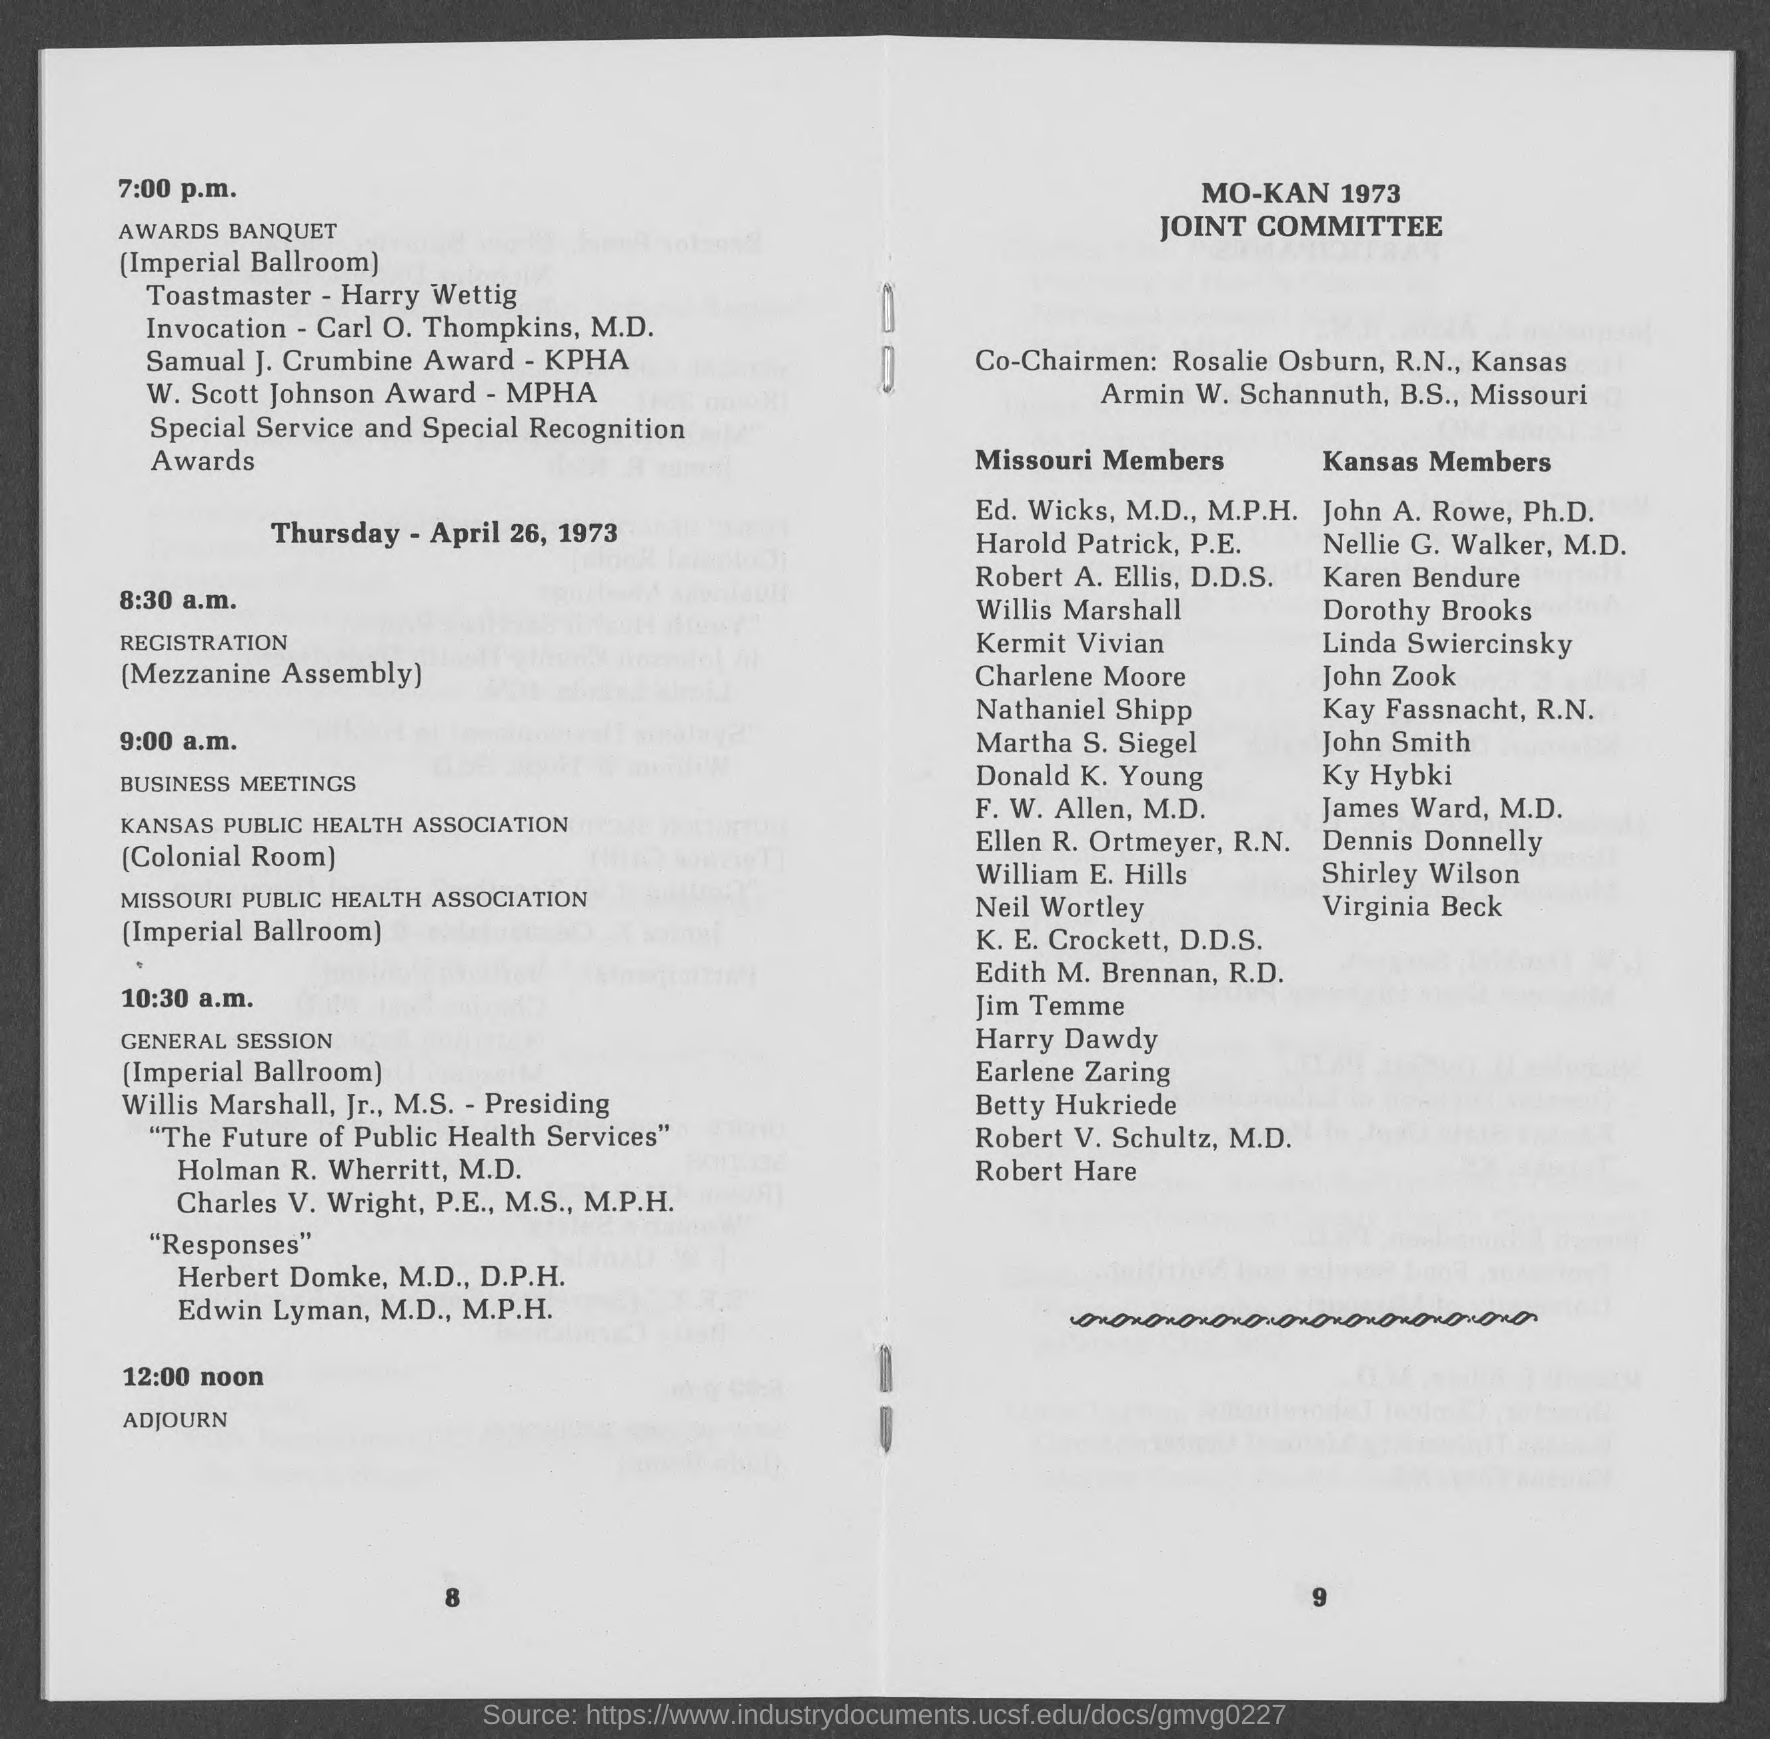What time is the registration for the sessions done?
Your response must be concise. 8:30 a.m. Where is the Awards Banquet held?
Your response must be concise. Imperial ballroom. What time is the business meetings of KANAS PUBLIC HEALTH ASSOCIATION scheduled?
Keep it short and to the point. 9:00 a.m. Where is the busines meetings of MISSOURI PUBLIC HEALTH ASSSOCIATION organized?
Offer a terse response. Imperial ballroom. 